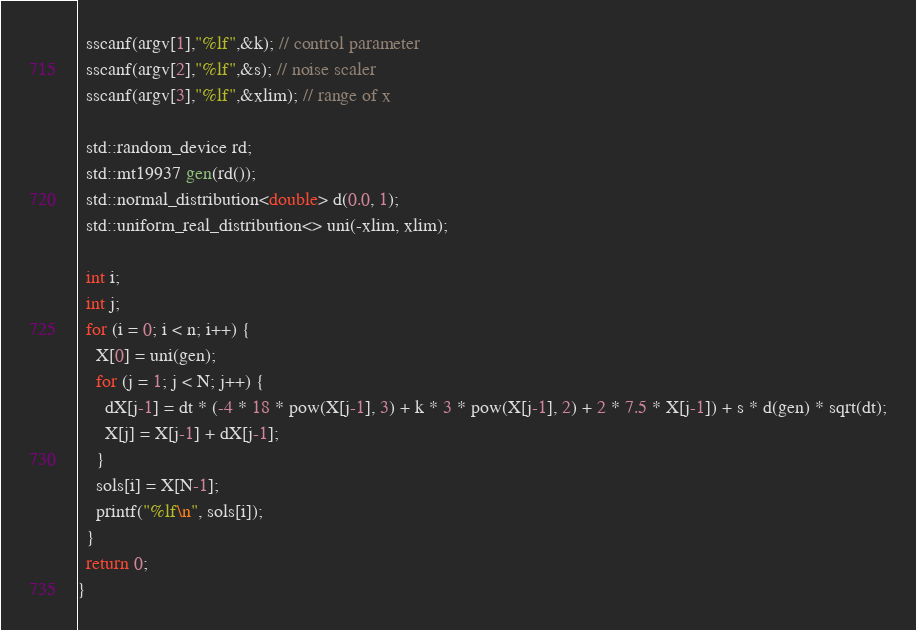Convert code to text. <code><loc_0><loc_0><loc_500><loc_500><_C++_>  sscanf(argv[1],"%lf",&k); // control parameter
  sscanf(argv[2],"%lf",&s); // noise scaler
  sscanf(argv[3],"%lf",&xlim); // range of x

  std::random_device rd;
  std::mt19937 gen(rd());
  std::normal_distribution<double> d(0.0, 1);
  std::uniform_real_distribution<> uni(-xlim, xlim);

  int i;
  int j;
  for (i = 0; i < n; i++) {
    X[0] = uni(gen);
    for (j = 1; j < N; j++) {
      dX[j-1] = dt * (-4 * 18 * pow(X[j-1], 3) + k * 3 * pow(X[j-1], 2) + 2 * 7.5 * X[j-1]) + s * d(gen) * sqrt(dt);
      X[j] = X[j-1] + dX[j-1];
    }
    sols[i] = X[N-1];
    printf("%lf\n", sols[i]);
  }
  return 0;
}
</code> 